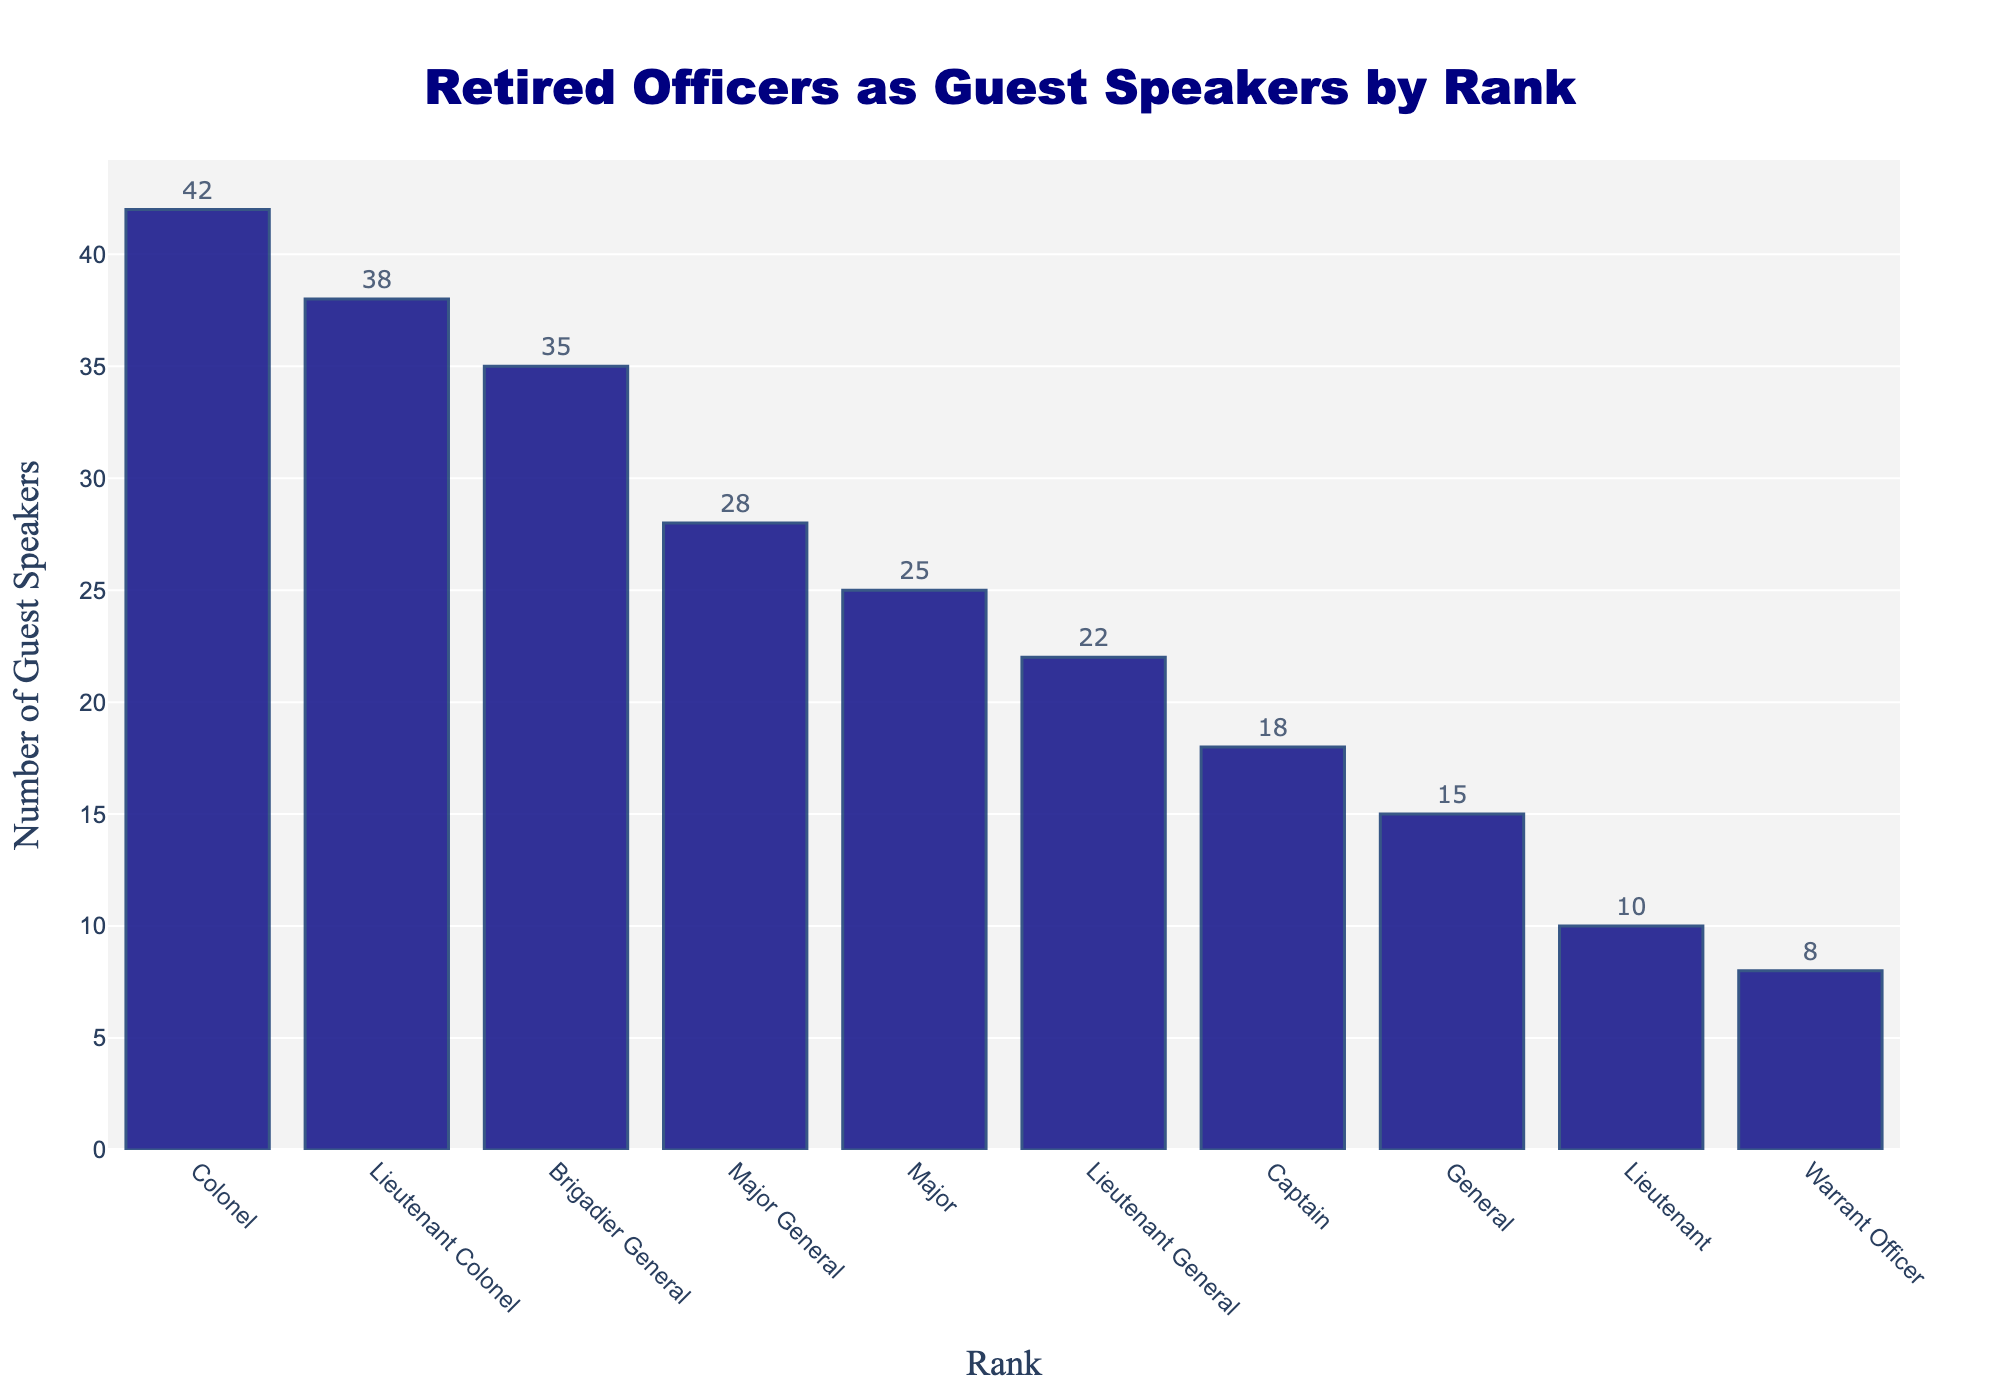What's the total number of retired officers in the rank of Major, Lieutenant, and Warrant Officer combined? Add the number of guest speakers for the ranks Major (25), Lieutenant (10), and Warrant Officer (8). So, 25 + 10 + 8 = 43
Answer: 43 Which rank has the highest number of guest speakers? Identify the rank with the tallest bar in the chart, which represents the highest number of guest speakers. This corresponds to the Colonel rank with 42 guest speakers.
Answer: Colonel How many more guest speakers does the rank of Lieutenant Colonel have compared to the rank of Captain? Subtract the number of guest speakers for Captain (18) from Lieutenant Colonel (38). So, 38 - 18 = 20
Answer: 20 What's the average number of guest speakers for the top three ranks by number of guest speakers? Sum the number of guest speakers for the top three ranks, which are Colonel (42), Lieutenant Colonel (38), and Brigadier General (35). Then, divide by 3. So, (42 + 38 + 35) / 3 = 115 / 3 ≈ 38.33
Answer: 38.33 Which ranks have fewer than 20 guest speakers? Identify all ranks having bars shorter than the 20 mark on the y-axis. The ranks are Lieutenant (10) and Warrant Officer (8).
Answer: Lieutenant and Warrant Officer How does the number of guest speakers for Brigadier General compare to that of Major General? Check the bar heights for Brigadier General (35) and Major General (28) to find that Brigadier General has more guest speakers. So, 35 > 28.
Answer: Brigadier General has more What's the median number of guest speakers across all ranks? Arrange the number of guest speakers in ascending order: 8, 10, 15, 18, 22, 25, 28, 35, 38, 42. The median is the average of the 5th and 6th values, (22 + 25) / 2 = 23.5
Answer: 23.5 What's the sum of the guest speakers in the ranks below Major General? Add the number of guest speakers for the ranks below Major General: Brigadier General (35), Colonel (42), Lieutenant Colonel (38), Major (25), Captain (18), Lieutenant (10), and Warrant Officer (8). So, 35 + 42 + 38 + 25 + 18 + 10 + 8 = 176
Answer: 176 